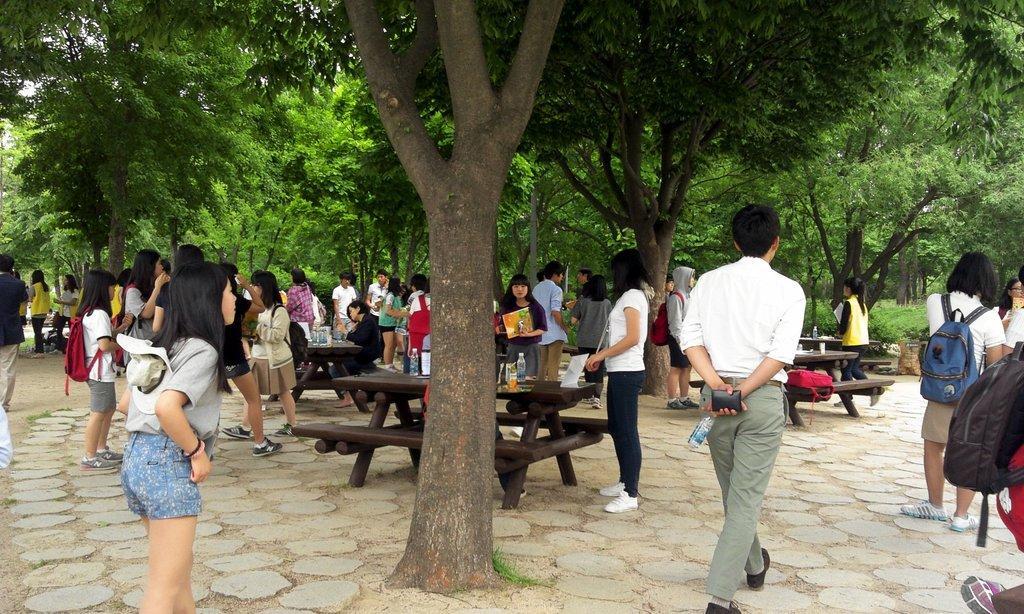Describe this image in one or two sentences. In this picture we can see a group of people standing on floor and some are walking carrying their bags and in front of them there are benches and tables and on table we can see bottles, laptop and in background we can see trees. 